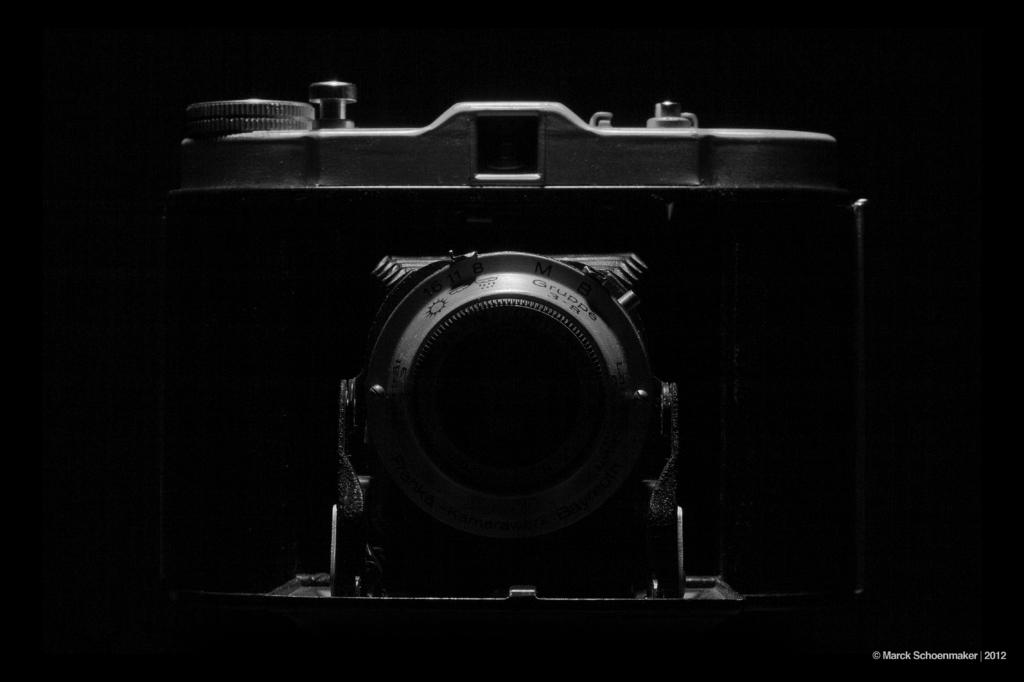What is the main subject of the image? The main subject of the image is a camera. Can you describe the background of the image? The background of the image is dark. Is there any additional information or branding visible in the image? Yes, there is a watermark in the bottom right of the image. What type of shoes can be seen in the image? There are no shoes present in the image; it features a camera with a dark background and a watermark. How many bananas are visible in the image? There are no bananas present in the image. 